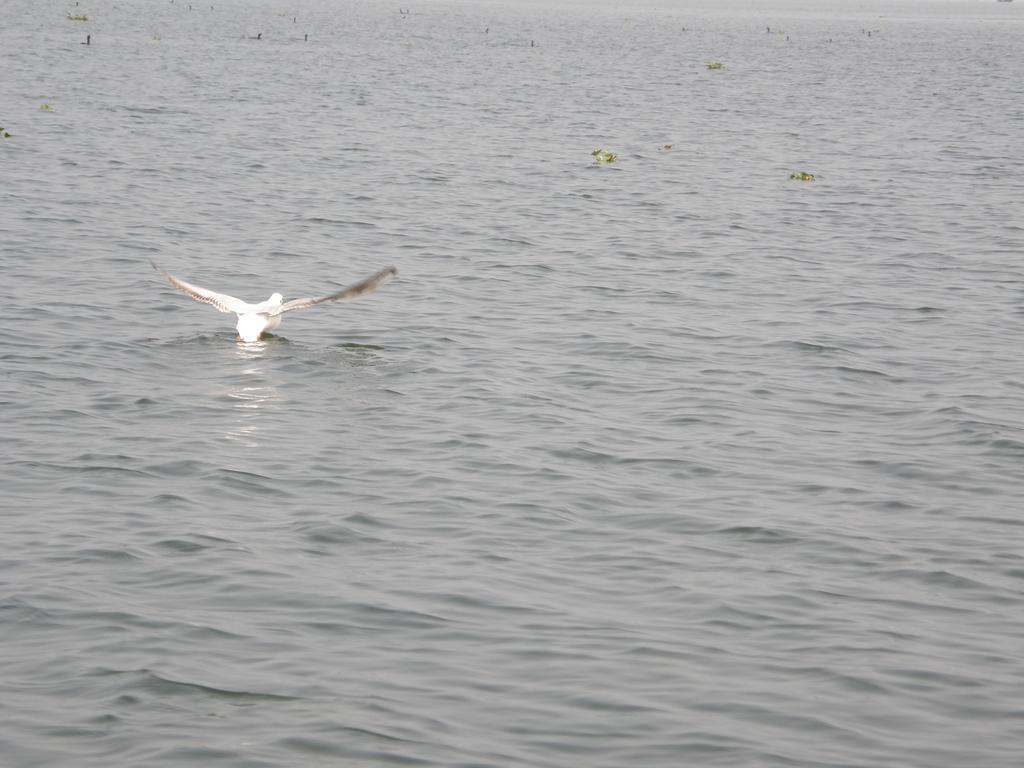Can you describe this image briefly? In this image I can see the bird on the water. I can see the water in ash color and the bird is in white color. 